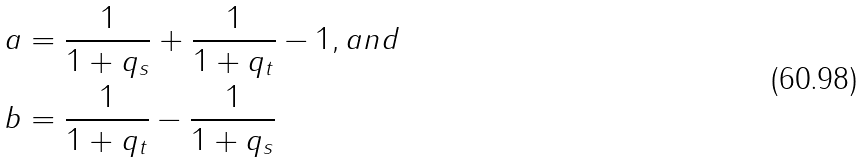Convert formula to latex. <formula><loc_0><loc_0><loc_500><loc_500>a & = \frac { 1 } { 1 + q _ { s } } + \frac { 1 } { 1 + q _ { t } } - 1 , a n d \\ b & = \frac { 1 } { 1 + q _ { t } } - \frac { 1 } { 1 + q _ { s } }</formula> 